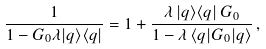<formula> <loc_0><loc_0><loc_500><loc_500>\frac { 1 } { 1 - G _ { 0 } \lambda | q \rangle \langle q | } = 1 + \frac { \lambda \, | q \rangle \langle q | \, G _ { 0 } } { 1 - \lambda \, \langle q | G _ { 0 } | q \rangle } \, ,</formula> 